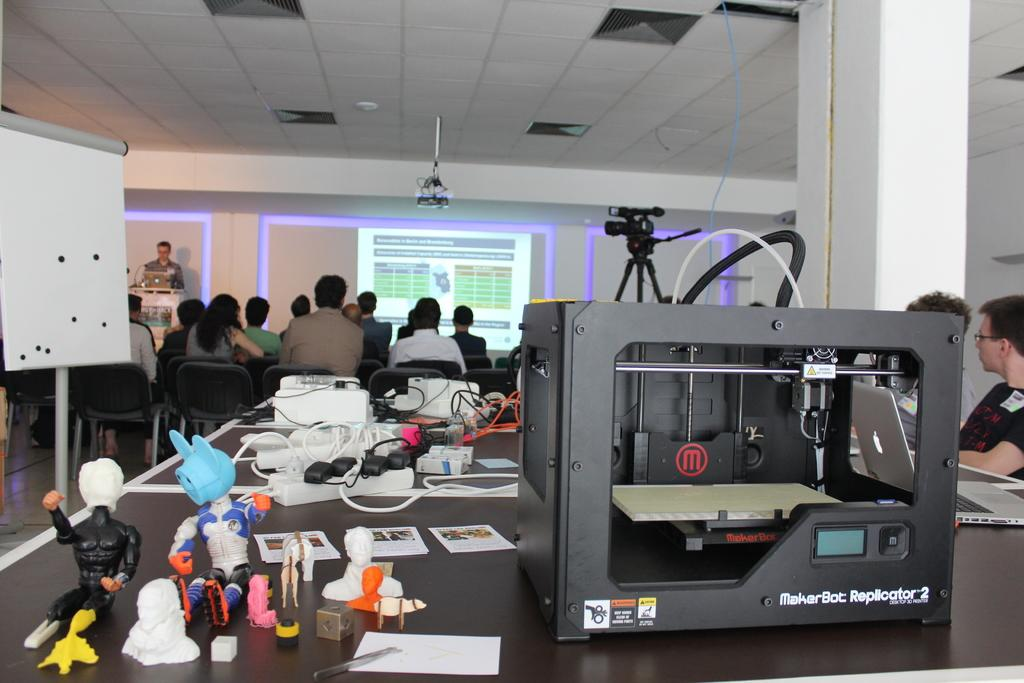<image>
Render a clear and concise summary of the photo. a gadget on a table reading MakerBot Replication with figurines next to it 